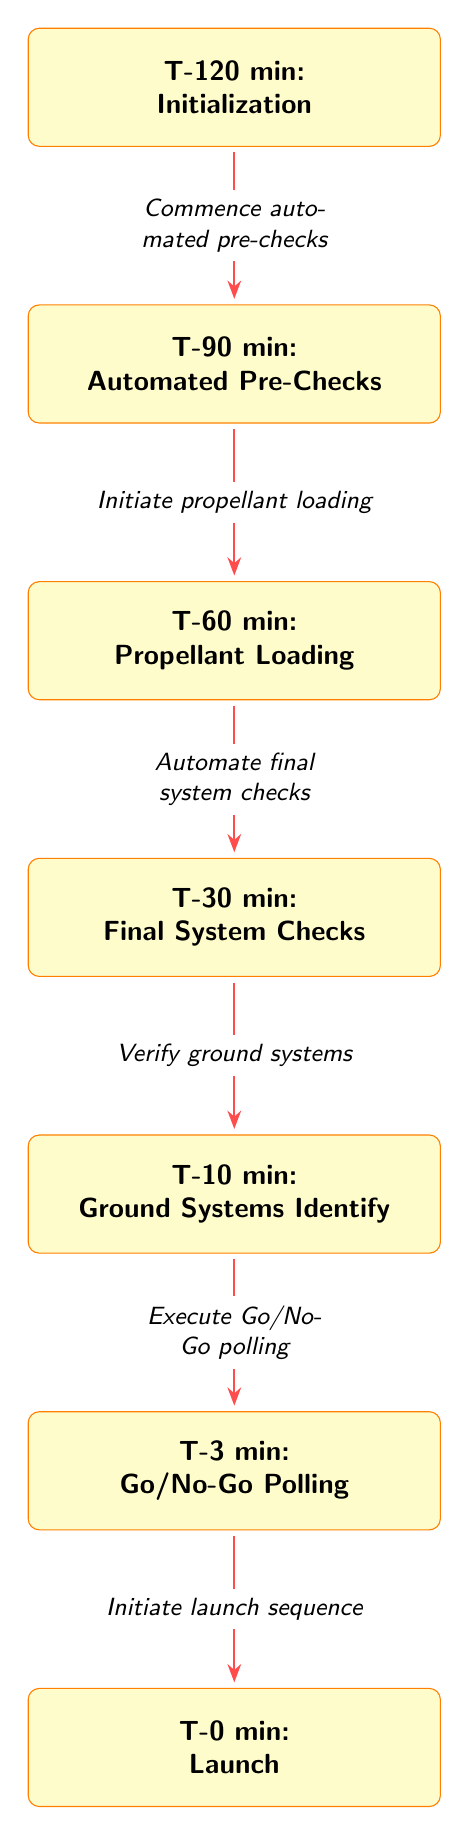What is the first node in the countdown process? The first node in the countdown process is labeled "T-120 min: Initialization." It is located at the top of the diagram, indicating the starting point.
Answer: T-120 min: Initialization How many nodes are present in the diagram? By counting each labeled rectangle from T-120 to T-0, we find a total of six nodes representing various stages of the countdown process.
Answer: 6 What action occurs at T-30 min? At T-30 min, the action that occurs is "Final System Checks," as indicated in the corresponding node.
Answer: Final System Checks Which node comes directly after T-10 min? The node that comes directly after T-10 min is T-3 min, as per the directional arrows representing the flow of the process.
Answer: T-3 min What is the relationship between T-60 min and T-90 min? The relationship is a sequential one where T-90 min flows into T-60 min, indicating that the steps at T-90 min precede those at T-60 min, specifically through the conducted actions.
Answer: T-90 min → T-60 min What is the last action before the launch? The last action before the launch, as represented in the final node, is "Initiate launch sequence," occurring at T-0 min.
Answer: Initiate launch sequence If the automated pre-checks fail at T-90 min, what happens next? In the sequence provided, if the automated pre-checks fail, the process would likely halt, and further steps would not be executed. The diagram does not specify an alternative workflow in this case.
Answer: Sequence halts What step immediately follows the "Verify ground systems" action? The step immediately following the "Verify ground systems" action at T-10 min is "Execute Go/No-Go polling" at T-3 min, indicating that this step is contingent upon the verification of ground systems.
Answer: Execute Go/No-Go polling What two actions are combined in the T-60 min node? The two actions combined in the T-60 min node are "Propellant Loading" with the initiation of this step marked specifically in the diagram.
Answer: Propellant Loading 